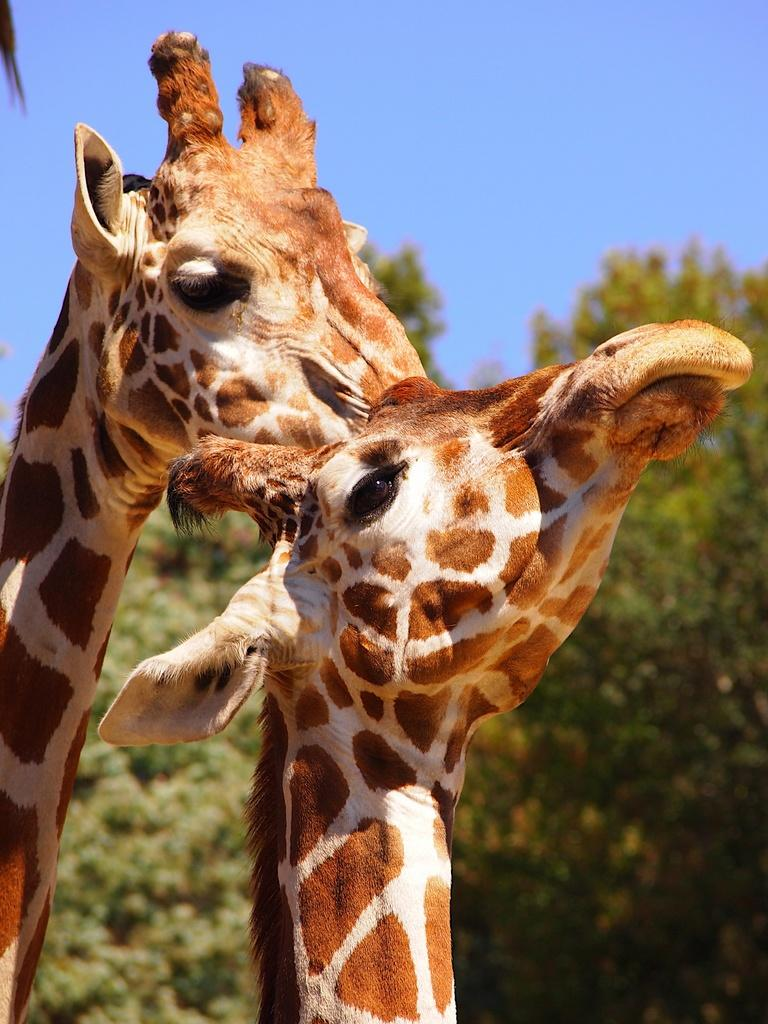What animals are in the foreground of the picture? There are giraffes in the foreground of the picture. What can be seen in the background of the picture? There are trees and the sky visible in the background of the picture. What color is the crayon being used by the giraffe in the picture? There is no crayon present in the image, as it features giraffes and a natural background. 